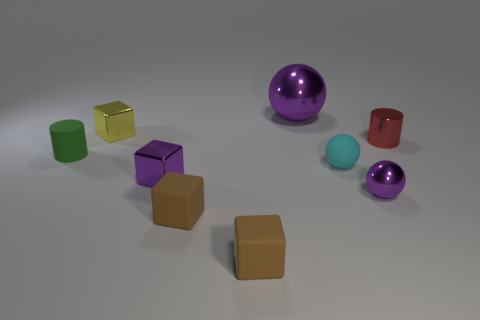Subtract all tiny purple shiny cubes. How many cubes are left? 3 Subtract all cyan cubes. Subtract all blue cylinders. How many cubes are left? 4 Subtract all cubes. How many objects are left? 5 Add 5 blue metallic objects. How many blue metallic objects exist? 5 Subtract 1 red cylinders. How many objects are left? 8 Subtract all tiny red things. Subtract all small yellow metallic cubes. How many objects are left? 7 Add 6 tiny purple balls. How many tiny purple balls are left? 7 